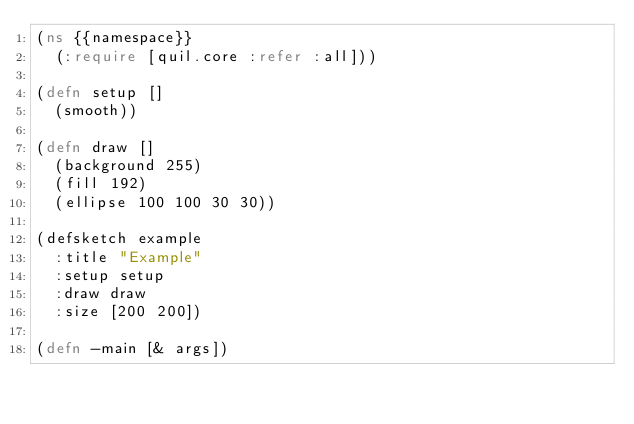Convert code to text. <code><loc_0><loc_0><loc_500><loc_500><_Clojure_>(ns {{namespace}}
  (:require [quil.core :refer :all]))

(defn setup []
  (smooth))

(defn draw []
  (background 255)
  (fill 192)
  (ellipse 100 100 30 30))

(defsketch example
  :title "Example"
  :setup setup
  :draw draw
  :size [200 200])

(defn -main [& args])
</code> 